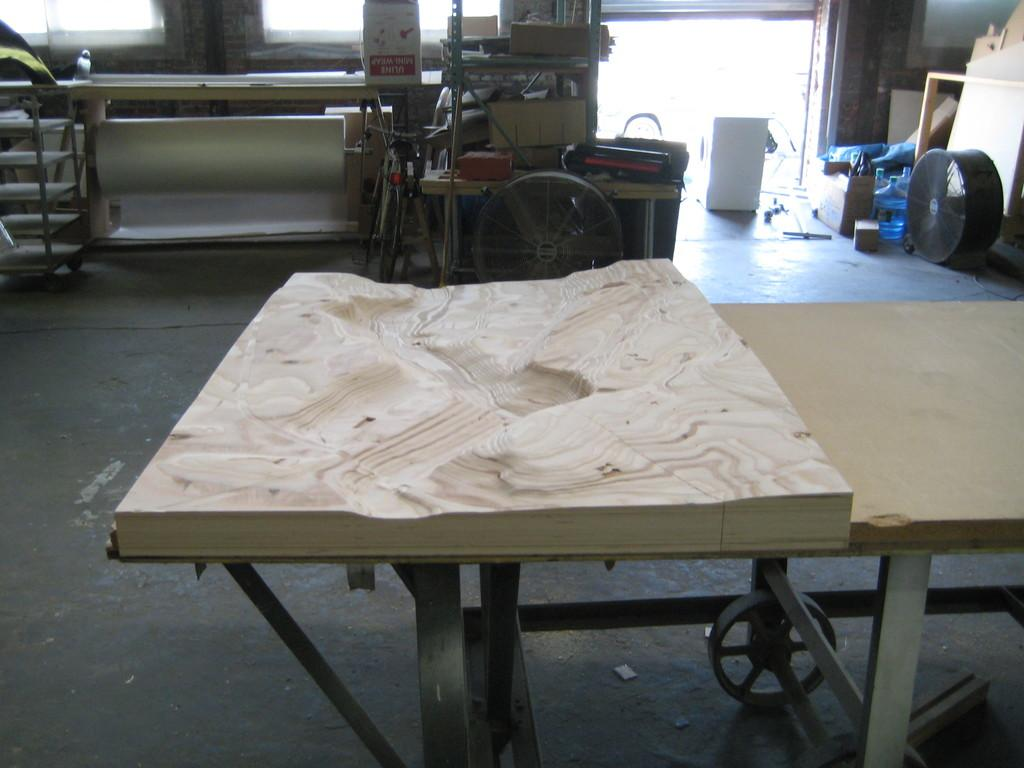What is on the table in the image? There is a wooden carving on the table. What feature can be seen on the wooden carving? Wheels are visible in the image. What type of objects can be seen in the image besides the wooden carving? There is furniture and a box on the floor in the image. What type of bean is growing on the floor in the image? There is no bean growing on the floor in the image. 